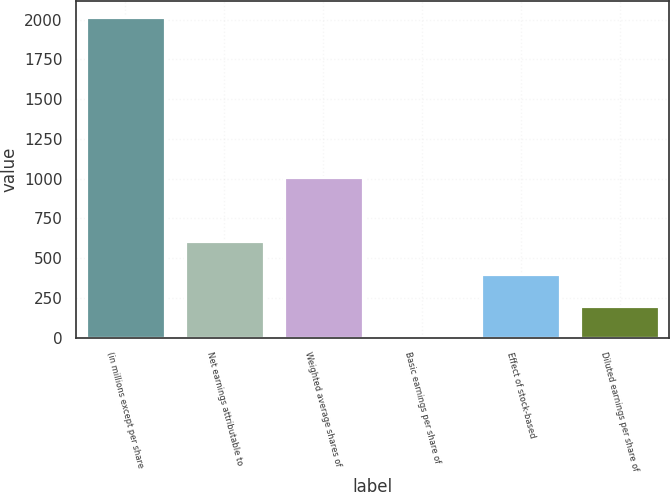Convert chart to OTSL. <chart><loc_0><loc_0><loc_500><loc_500><bar_chart><fcel>(in millions except per share<fcel>Net earnings attributable to<fcel>Weighted average shares of<fcel>Basic earnings per share of<fcel>Effect of stock-based<fcel>Diluted earnings per share of<nl><fcel>2016<fcel>605.18<fcel>1008.27<fcel>0.55<fcel>403.64<fcel>202.1<nl></chart> 